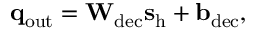<formula> <loc_0><loc_0><loc_500><loc_500>q _ { o u t } = W _ { d e c } s _ { h } + b _ { d e c } ,</formula> 